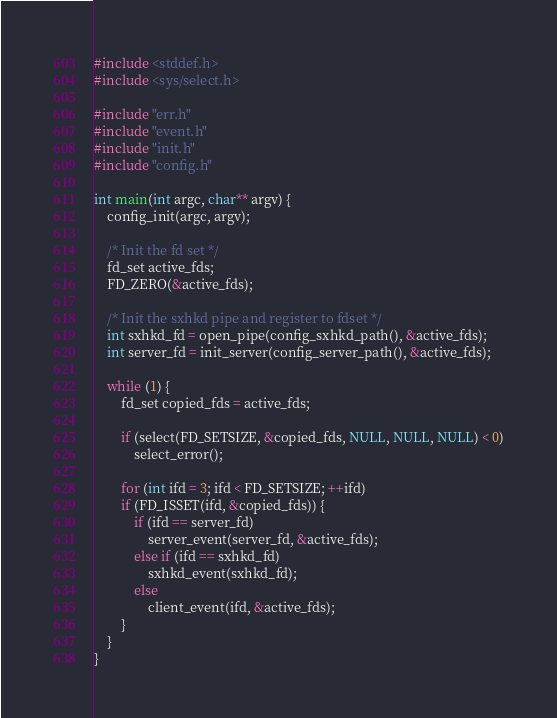<code> <loc_0><loc_0><loc_500><loc_500><_C_>#include <stddef.h>
#include <sys/select.h>

#include "err.h"
#include "event.h"
#include "init.h"
#include "config.h"

int main(int argc, char** argv) {
    config_init(argc, argv);

    /* Init the fd set */
    fd_set active_fds;
    FD_ZERO(&active_fds);

    /* Init the sxhkd pipe and register to fdset */
    int sxhkd_fd = open_pipe(config_sxhkd_path(), &active_fds);
    int server_fd = init_server(config_server_path(), &active_fds);

    while (1) {
        fd_set copied_fds = active_fds;

        if (select(FD_SETSIZE, &copied_fds, NULL, NULL, NULL) < 0)
            select_error();

        for (int ifd = 3; ifd < FD_SETSIZE; ++ifd)
        if (FD_ISSET(ifd, &copied_fds)) {
            if (ifd == server_fd)
                server_event(server_fd, &active_fds);
            else if (ifd == sxhkd_fd)
                sxhkd_event(sxhkd_fd);
            else
                client_event(ifd, &active_fds);
        }
    }
}
</code> 